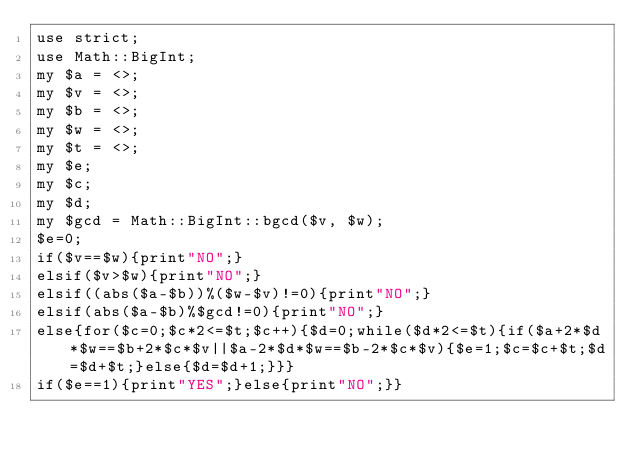<code> <loc_0><loc_0><loc_500><loc_500><_Perl_>use strict;
use Math::BigInt;
my $a = <>;
my $v = <>;
my $b = <>;
my $w = <>;
my $t = <>;
my $e;
my $c;
my $d;
my $gcd = Math::BigInt::bgcd($v, $w);
$e=0;
if($v==$w){print"NO";}
elsif($v>$w){print"NO";}
elsif((abs($a-$b))%($w-$v)!=0){print"NO";}
elsif(abs($a-$b)%$gcd!=0){print"NO";}
else{for($c=0;$c*2<=$t;$c++){$d=0;while($d*2<=$t){if($a+2*$d*$w==$b+2*$c*$v||$a-2*$d*$w==$b-2*$c*$v){$e=1;$c=$c+$t;$d=$d+$t;}else{$d=$d+1;}}}
if($e==1){print"YES";}else{print"NO";}}</code> 